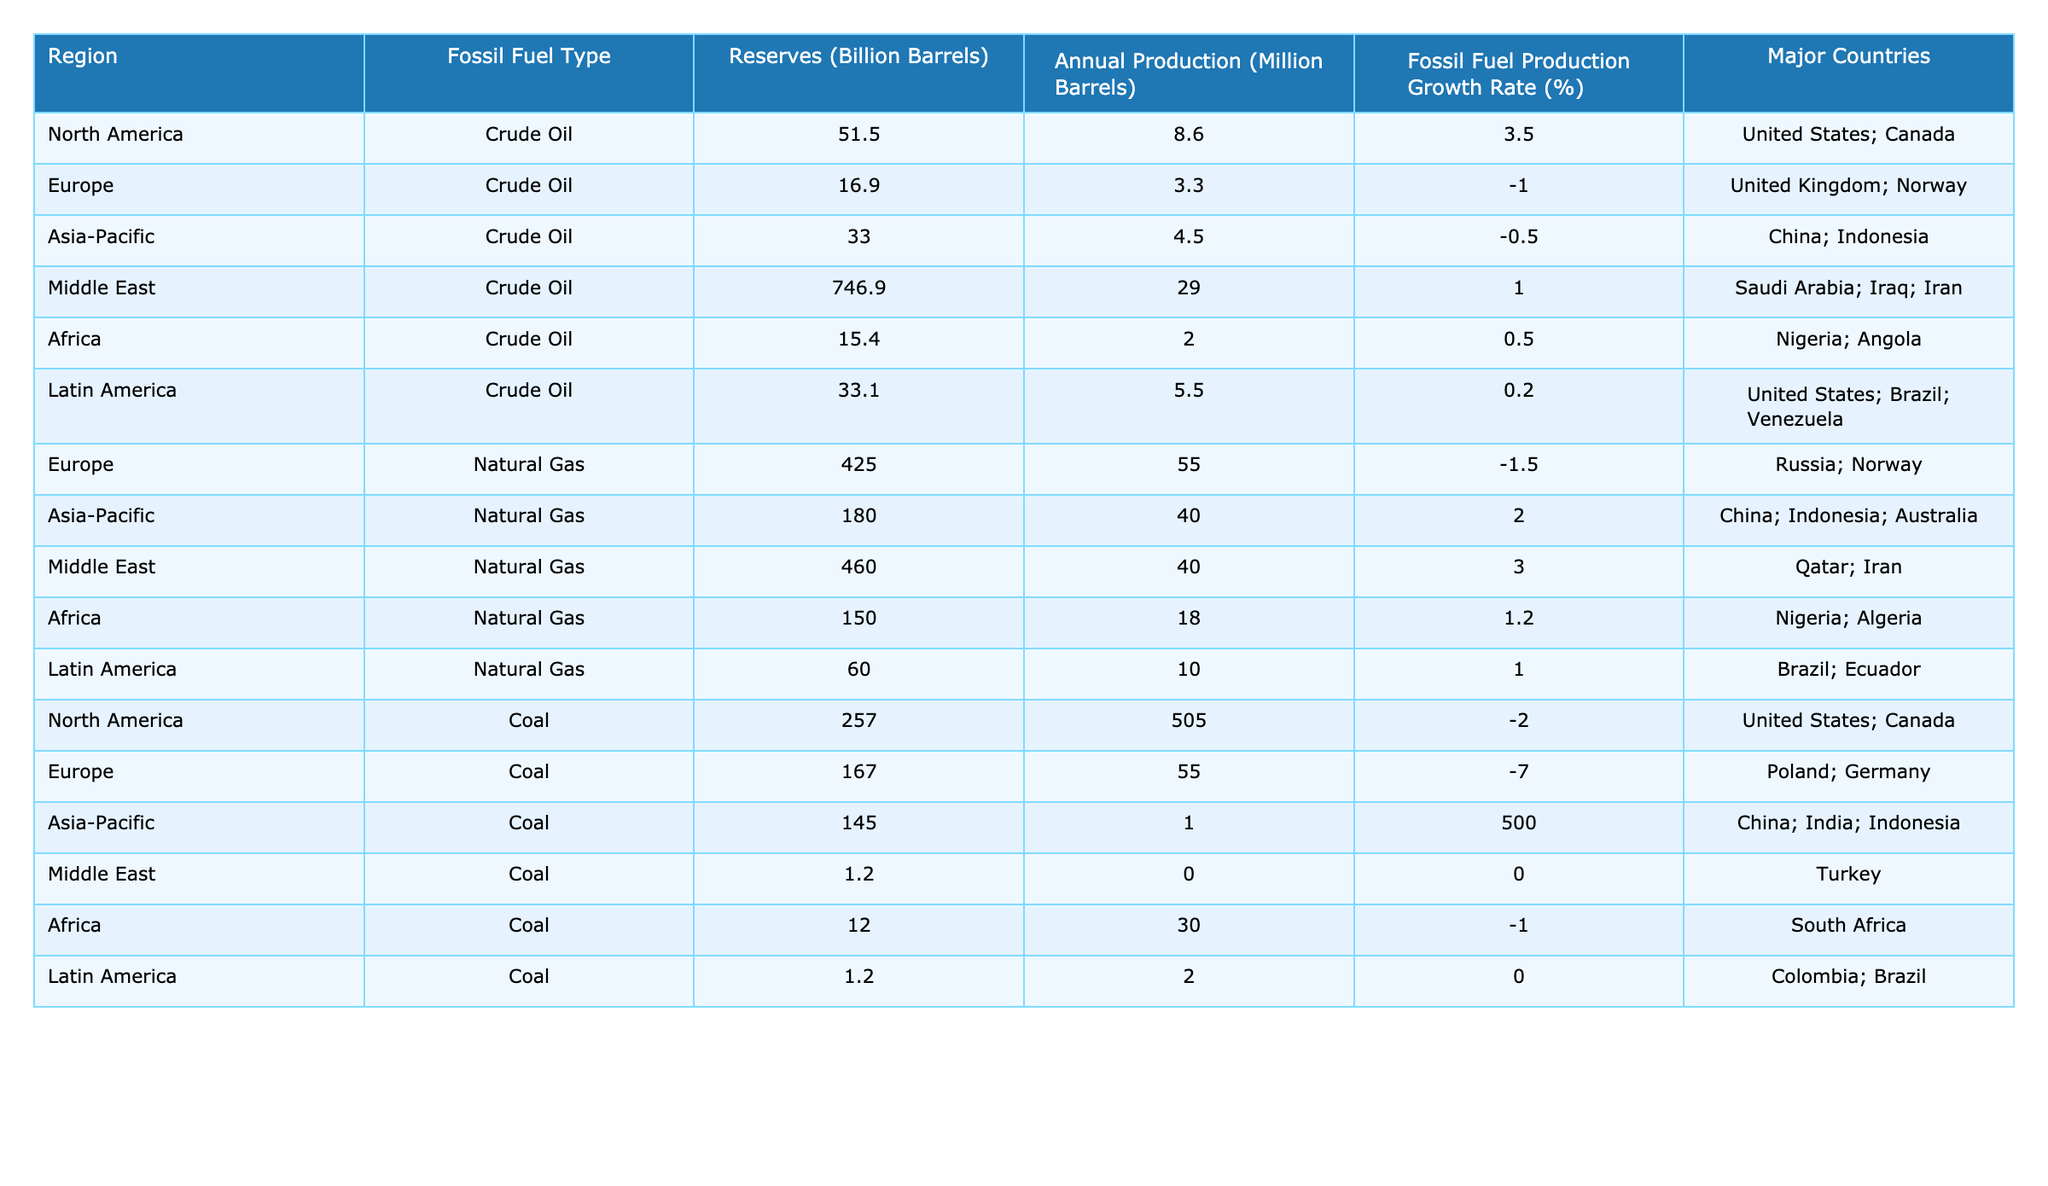What region has the highest crude oil reserves? The table lists crude oil reserves by region. The Middle East has the highest reserves at 746.9 billion barrels.
Answer: Middle East Which fossil fuel type has the largest annual production in North America? In North America, the annual production for coal is 505 million barrels, while for crude oil it is 8.6 million barrels. Coal has the largest production.
Answer: Coal What is the production growth rate for natural gas in Asia-Pacific? The table shows that the fossil fuel production growth rate for natural gas in Asia-Pacific is 2.0%.
Answer: 2.0% How many million barrels of crude oil does Africa produce annually? According to the table, Africa's annual production of crude oil is 2.0 million barrels.
Answer: 2.0 What is the average crude oil reserves across all regions listed? The reserves are: North America (51.5), Europe (16.9), Asia-Pacific (33.0), Middle East (746.9), Africa (15.4), and Latin America (33.1). The total reserves are 896.8 billion barrels, so the average is 896.8 / 6 = 149.47 billion barrels.
Answer: 149.47 Is it true that Europe has more natural gas reserves than North America? Europe has 425.0 billion barrels of natural gas reserves, while North America has 0 reserves listed for natural gas. Thus, this statement is true.
Answer: Yes Which region has the lowest annual production of coal? The table shows that the Middle East has the lowest annual coal production at 0.0 million barrels.
Answer: Middle East What is the total coal production for Asia-Pacific and North America combined? For Asia-Pacific, total coal production is 1,500.0 million barrels and for North America it is 505.0 million barrels. Adding these yields 1,500 + 505 = 2,005 million barrels.
Answer: 2,005 In which region is natural gas production declining the most? The production growth rate for natural gas in Europe is -1.5%, which indicates it is declining the most.
Answer: Europe Which region among the listed has the highest fossil fuel production growth rate? The highest growth rate is for natural gas in the Middle East at 3.0%.
Answer: Middle East 